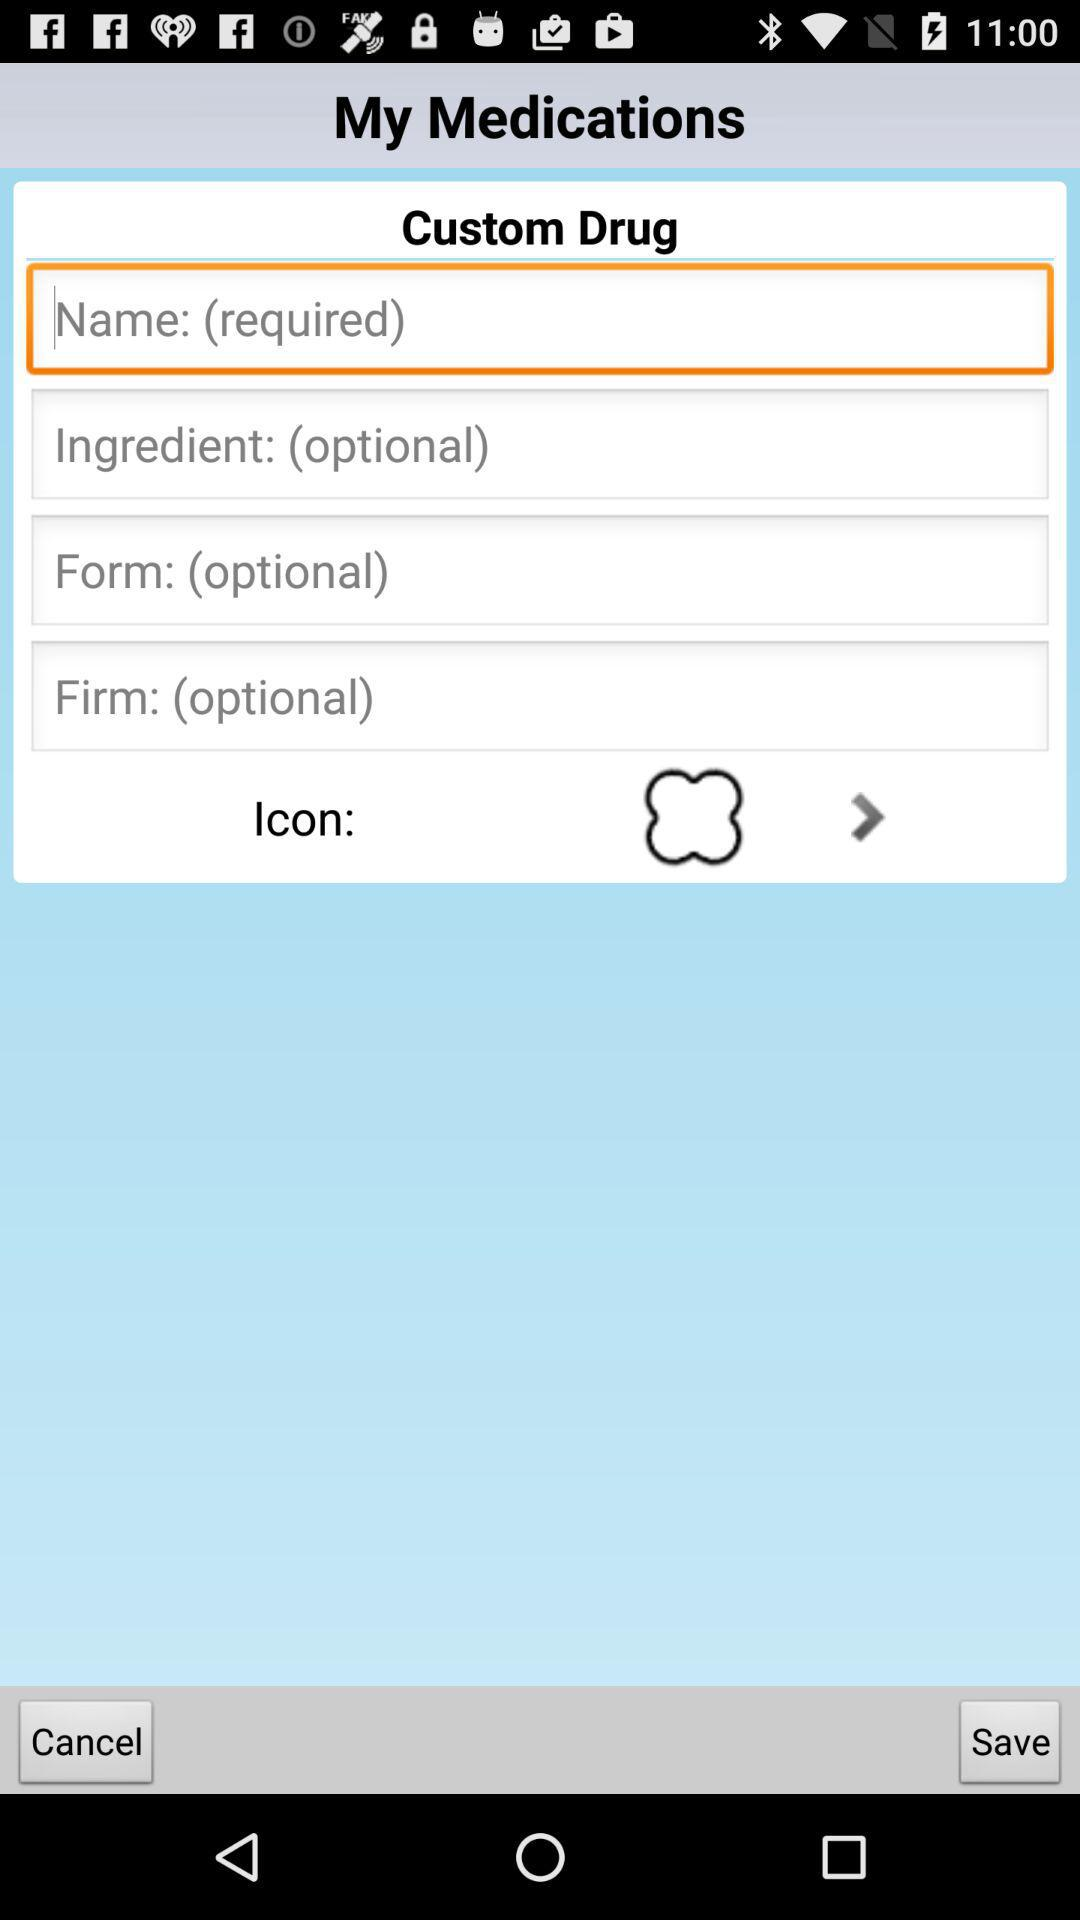Is the ingredient required or optional? The ingredient is optional. 